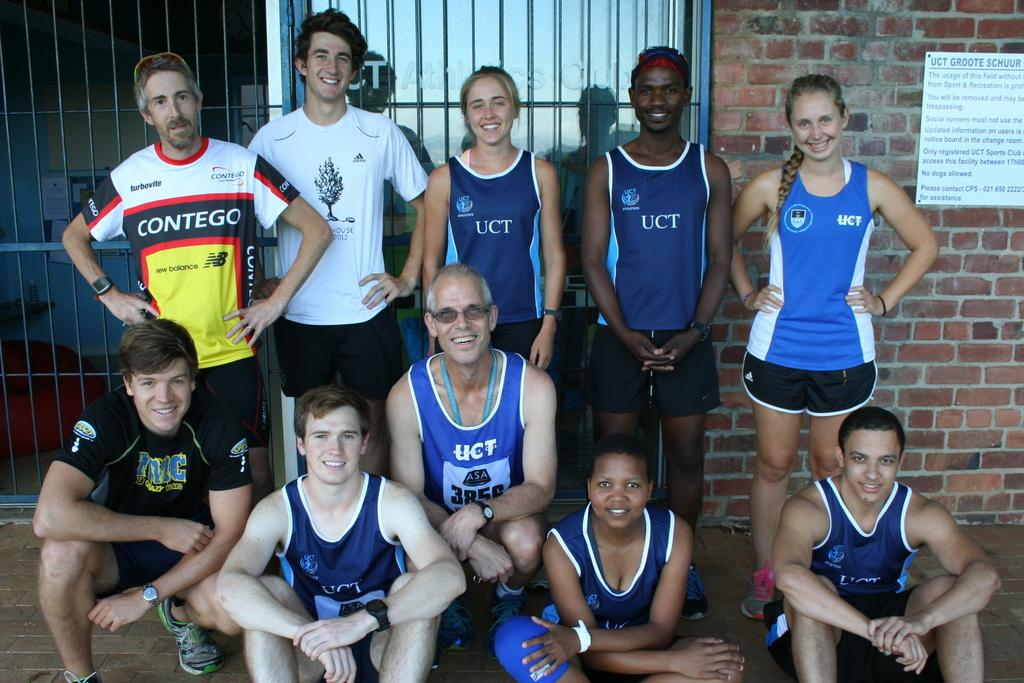<image>
Share a concise interpretation of the image provided. People in blue sports jerseys with UCT on them 